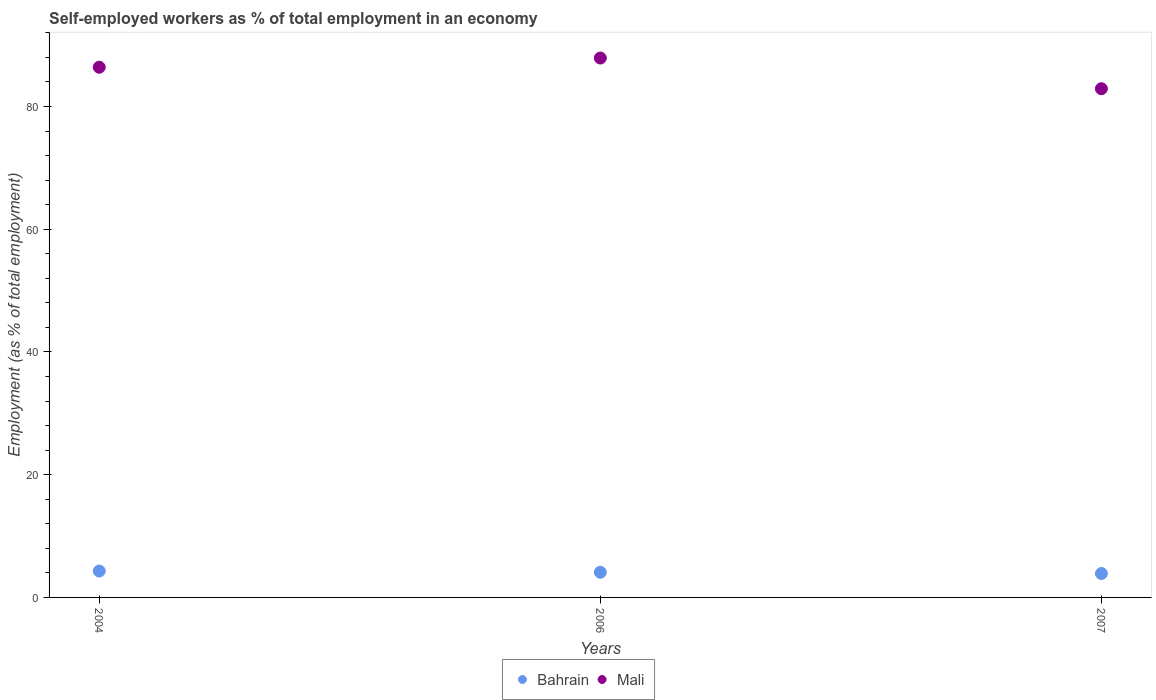What is the percentage of self-employed workers in Bahrain in 2004?
Ensure brevity in your answer.  4.3. Across all years, what is the maximum percentage of self-employed workers in Mali?
Give a very brief answer. 87.9. Across all years, what is the minimum percentage of self-employed workers in Bahrain?
Keep it short and to the point. 3.9. In which year was the percentage of self-employed workers in Bahrain maximum?
Ensure brevity in your answer.  2004. In which year was the percentage of self-employed workers in Bahrain minimum?
Your response must be concise. 2007. What is the total percentage of self-employed workers in Bahrain in the graph?
Provide a succinct answer. 12.3. What is the difference between the percentage of self-employed workers in Bahrain in 2004 and the percentage of self-employed workers in Mali in 2007?
Give a very brief answer. -78.6. What is the average percentage of self-employed workers in Bahrain per year?
Offer a terse response. 4.1. In the year 2006, what is the difference between the percentage of self-employed workers in Mali and percentage of self-employed workers in Bahrain?
Provide a short and direct response. 83.8. What is the ratio of the percentage of self-employed workers in Mali in 2004 to that in 2006?
Give a very brief answer. 0.98. Is the percentage of self-employed workers in Mali in 2004 less than that in 2006?
Your response must be concise. Yes. Is the difference between the percentage of self-employed workers in Mali in 2006 and 2007 greater than the difference between the percentage of self-employed workers in Bahrain in 2006 and 2007?
Give a very brief answer. Yes. What is the difference between the highest and the second highest percentage of self-employed workers in Mali?
Your response must be concise. 1.5. What is the difference between the highest and the lowest percentage of self-employed workers in Mali?
Provide a short and direct response. 5. In how many years, is the percentage of self-employed workers in Bahrain greater than the average percentage of self-employed workers in Bahrain taken over all years?
Keep it short and to the point. 1. Is the percentage of self-employed workers in Mali strictly less than the percentage of self-employed workers in Bahrain over the years?
Ensure brevity in your answer.  No. How many years are there in the graph?
Provide a short and direct response. 3. What is the difference between two consecutive major ticks on the Y-axis?
Ensure brevity in your answer.  20. Does the graph contain any zero values?
Offer a terse response. No. How many legend labels are there?
Offer a terse response. 2. What is the title of the graph?
Provide a short and direct response. Self-employed workers as % of total employment in an economy. What is the label or title of the X-axis?
Offer a terse response. Years. What is the label or title of the Y-axis?
Your answer should be very brief. Employment (as % of total employment). What is the Employment (as % of total employment) in Bahrain in 2004?
Provide a short and direct response. 4.3. What is the Employment (as % of total employment) of Mali in 2004?
Give a very brief answer. 86.4. What is the Employment (as % of total employment) in Bahrain in 2006?
Keep it short and to the point. 4.1. What is the Employment (as % of total employment) of Mali in 2006?
Your answer should be very brief. 87.9. What is the Employment (as % of total employment) in Bahrain in 2007?
Ensure brevity in your answer.  3.9. What is the Employment (as % of total employment) in Mali in 2007?
Your response must be concise. 82.9. Across all years, what is the maximum Employment (as % of total employment) of Bahrain?
Ensure brevity in your answer.  4.3. Across all years, what is the maximum Employment (as % of total employment) in Mali?
Keep it short and to the point. 87.9. Across all years, what is the minimum Employment (as % of total employment) in Bahrain?
Provide a succinct answer. 3.9. Across all years, what is the minimum Employment (as % of total employment) of Mali?
Keep it short and to the point. 82.9. What is the total Employment (as % of total employment) of Mali in the graph?
Your response must be concise. 257.2. What is the difference between the Employment (as % of total employment) in Bahrain in 2004 and that in 2007?
Provide a short and direct response. 0.4. What is the difference between the Employment (as % of total employment) in Bahrain in 2004 and the Employment (as % of total employment) in Mali in 2006?
Your answer should be compact. -83.6. What is the difference between the Employment (as % of total employment) in Bahrain in 2004 and the Employment (as % of total employment) in Mali in 2007?
Offer a very short reply. -78.6. What is the difference between the Employment (as % of total employment) in Bahrain in 2006 and the Employment (as % of total employment) in Mali in 2007?
Give a very brief answer. -78.8. What is the average Employment (as % of total employment) of Mali per year?
Make the answer very short. 85.73. In the year 2004, what is the difference between the Employment (as % of total employment) in Bahrain and Employment (as % of total employment) in Mali?
Keep it short and to the point. -82.1. In the year 2006, what is the difference between the Employment (as % of total employment) in Bahrain and Employment (as % of total employment) in Mali?
Give a very brief answer. -83.8. In the year 2007, what is the difference between the Employment (as % of total employment) of Bahrain and Employment (as % of total employment) of Mali?
Give a very brief answer. -79. What is the ratio of the Employment (as % of total employment) of Bahrain in 2004 to that in 2006?
Your answer should be compact. 1.05. What is the ratio of the Employment (as % of total employment) in Mali in 2004 to that in 2006?
Offer a very short reply. 0.98. What is the ratio of the Employment (as % of total employment) in Bahrain in 2004 to that in 2007?
Offer a terse response. 1.1. What is the ratio of the Employment (as % of total employment) in Mali in 2004 to that in 2007?
Ensure brevity in your answer.  1.04. What is the ratio of the Employment (as % of total employment) in Bahrain in 2006 to that in 2007?
Keep it short and to the point. 1.05. What is the ratio of the Employment (as % of total employment) in Mali in 2006 to that in 2007?
Offer a terse response. 1.06. What is the difference between the highest and the lowest Employment (as % of total employment) in Bahrain?
Provide a succinct answer. 0.4. What is the difference between the highest and the lowest Employment (as % of total employment) in Mali?
Make the answer very short. 5. 